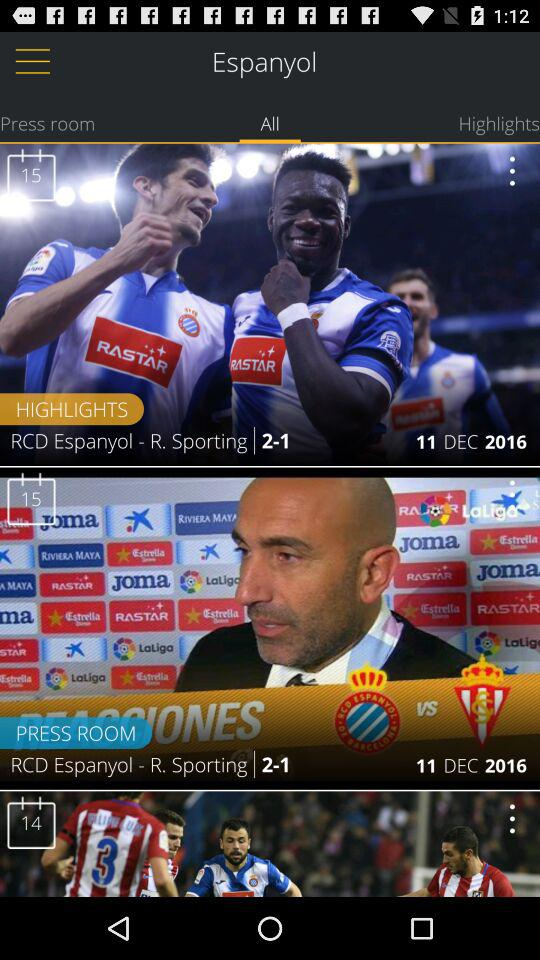What is the score of RCD Espanyol-R. Sporting? The score of RCD Espanyol-R. Sporting is 2-1. 